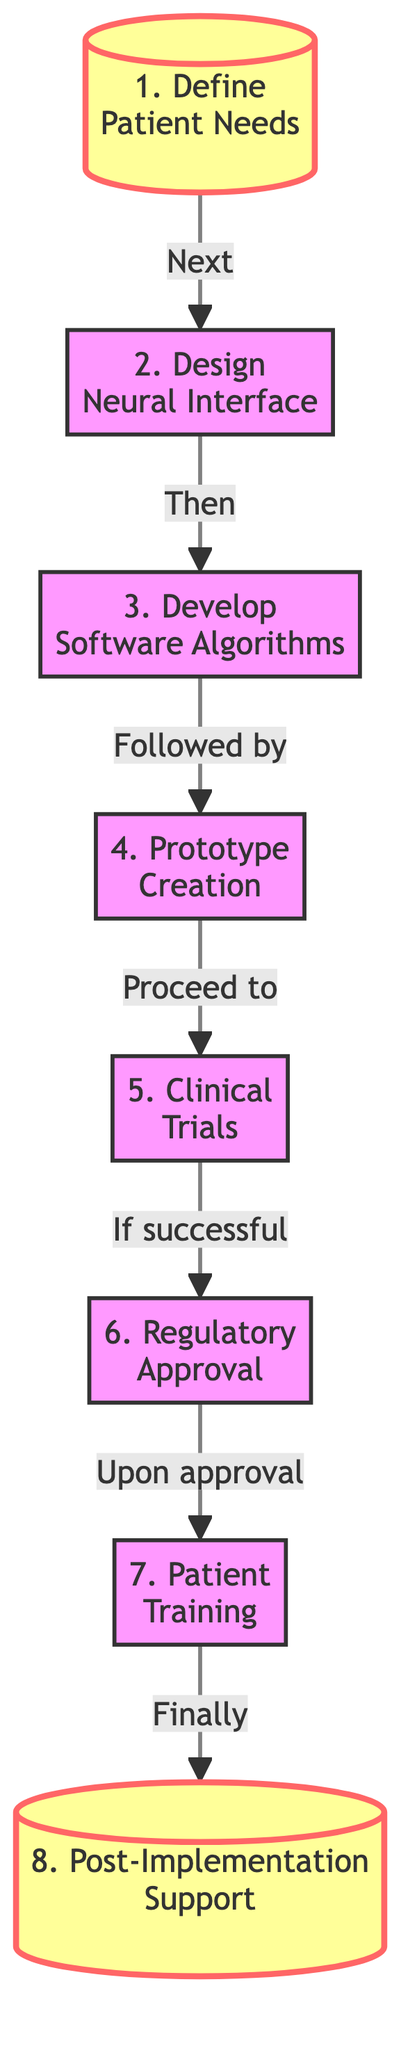What's the first step in creating a neural prosthetic? The diagram indicates the first step is to "Define Patient Needs." This is the initial action taken before any other processes can begin.
Answer: Define Patient Needs How many steps are involved in the process? Counting all the steps listed in the diagram from 1 to 8 reveals a total of eight steps in creating a neural prosthetic.
Answer: Eight What is the last step in the flow chart? The flow chart shows that the final step after all preceding actions is "Post-Implementation Support." Therefore, this is the last step of the entire process.
Answer: Post-Implementation Support Which step follows the "Prototype Creation"? According to the flow of the diagram, "Prototype Creation" is followed by "Clinical Trials," indicating the next necessary action in the process.
Answer: Clinical Trials What needs to occur before obtaining regulatory approval? The diagram states that "Clinical Trials" must be conducted and deemed successful before "Regulatory Approval" can be obtained, signifying a dependency in the process.
Answer: Clinical Trials What step involves teaching? The diagram clearly indicates that "Patient Training" pertains directly to the process of teaching patients how to effectively use the neural prosthetic after it has been developed and approved.
Answer: Patient Training What type of approval is needed after clinical trials? The flow chart specifies that "Regulatory Approval" is required following successful clinical trials, which is essential for medical use.
Answer: Regulatory Approval How do the steps relate to each other? The diagram shows a sequential relationship where each step must be completed before moving on to the next, demonstrating a clear workflow from defining needs to providing support.
Answer: Sequential What is the relationship between "Develop Software Algorithms" and "Prototype Creation"? The diagram indicates that "Develop Software Algorithms" is a step that directly precedes "Prototype Creation," showing that algorithms must be developed before a prototype is created.
Answer: Develop Software Algorithms 